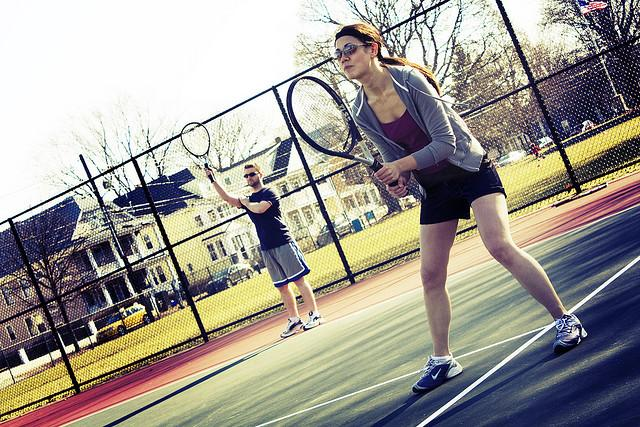What configuration of tennis is being played here? Please explain your reasoning. doubles. Doubles are played with two people to a side. 